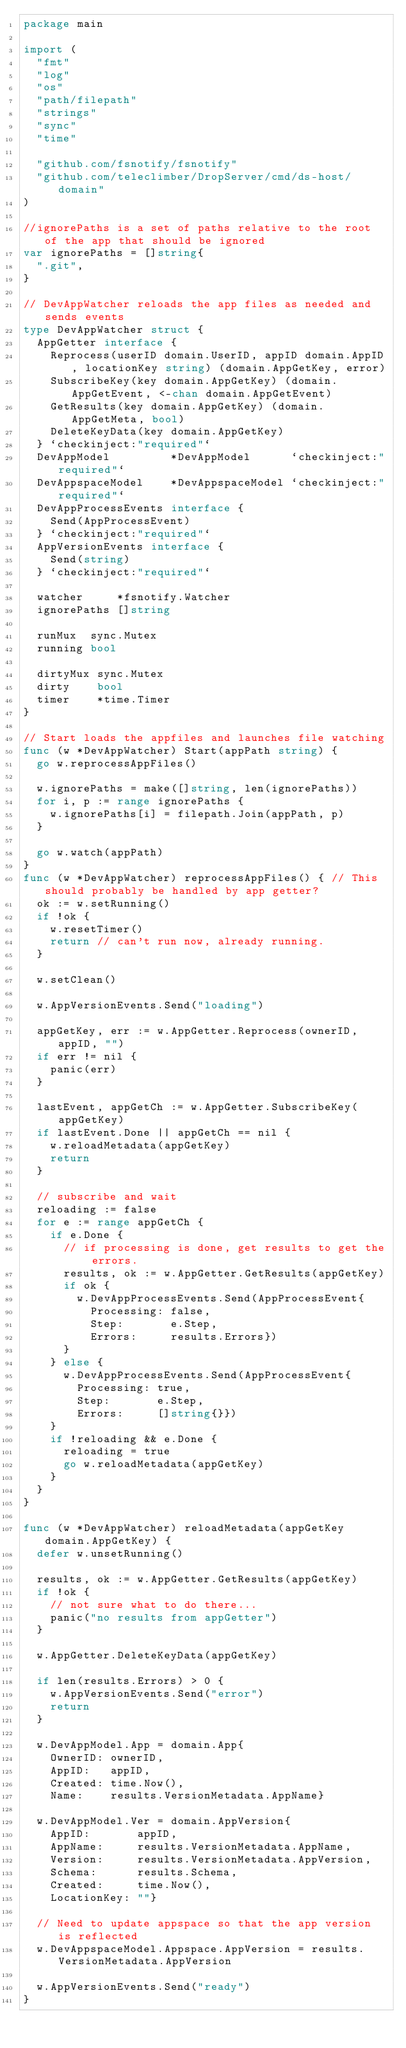<code> <loc_0><loc_0><loc_500><loc_500><_Go_>package main

import (
	"fmt"
	"log"
	"os"
	"path/filepath"
	"strings"
	"sync"
	"time"

	"github.com/fsnotify/fsnotify"
	"github.com/teleclimber/DropServer/cmd/ds-host/domain"
)

//ignorePaths is a set of paths relative to the root of the app that should be ignored
var ignorePaths = []string{
	".git",
}

// DevAppWatcher reloads the app files as needed and sends events
type DevAppWatcher struct {
	AppGetter interface {
		Reprocess(userID domain.UserID, appID domain.AppID, locationKey string) (domain.AppGetKey, error)
		SubscribeKey(key domain.AppGetKey) (domain.AppGetEvent, <-chan domain.AppGetEvent)
		GetResults(key domain.AppGetKey) (domain.AppGetMeta, bool)
		DeleteKeyData(key domain.AppGetKey)
	} `checkinject:"required"`
	DevAppModel         *DevAppModel      `checkinject:"required"`
	DevAppspaceModel    *DevAppspaceModel `checkinject:"required"`
	DevAppProcessEvents interface {
		Send(AppProcessEvent)
	} `checkinject:"required"`
	AppVersionEvents interface {
		Send(string)
	} `checkinject:"required"`

	watcher     *fsnotify.Watcher
	ignorePaths []string

	runMux  sync.Mutex
	running bool

	dirtyMux sync.Mutex
	dirty    bool
	timer    *time.Timer
}

// Start loads the appfiles and launches file watching
func (w *DevAppWatcher) Start(appPath string) {
	go w.reprocessAppFiles()

	w.ignorePaths = make([]string, len(ignorePaths))
	for i, p := range ignorePaths {
		w.ignorePaths[i] = filepath.Join(appPath, p)
	}

	go w.watch(appPath)
}
func (w *DevAppWatcher) reprocessAppFiles() { // This should probably be handled by app getter?
	ok := w.setRunning()
	if !ok {
		w.resetTimer()
		return // can't run now, already running.
	}

	w.setClean()

	w.AppVersionEvents.Send("loading")

	appGetKey, err := w.AppGetter.Reprocess(ownerID, appID, "")
	if err != nil {
		panic(err)
	}

	lastEvent, appGetCh := w.AppGetter.SubscribeKey(appGetKey)
	if lastEvent.Done || appGetCh == nil {
		w.reloadMetadata(appGetKey)
		return
	}

	// subscribe and wait
	reloading := false
	for e := range appGetCh {
		if e.Done {
			// if processing is done, get results to get the errors.
			results, ok := w.AppGetter.GetResults(appGetKey)
			if ok {
				w.DevAppProcessEvents.Send(AppProcessEvent{
					Processing: false,
					Step:       e.Step,
					Errors:     results.Errors})
			}
		} else {
			w.DevAppProcessEvents.Send(AppProcessEvent{
				Processing: true,
				Step:       e.Step,
				Errors:     []string{}})
		}
		if !reloading && e.Done {
			reloading = true
			go w.reloadMetadata(appGetKey)
		}
	}
}

func (w *DevAppWatcher) reloadMetadata(appGetKey domain.AppGetKey) {
	defer w.unsetRunning()

	results, ok := w.AppGetter.GetResults(appGetKey)
	if !ok {
		// not sure what to do there...
		panic("no results from appGetter")
	}

	w.AppGetter.DeleteKeyData(appGetKey)

	if len(results.Errors) > 0 {
		w.AppVersionEvents.Send("error")
		return
	}

	w.DevAppModel.App = domain.App{
		OwnerID: ownerID,
		AppID:   appID,
		Created: time.Now(),
		Name:    results.VersionMetadata.AppName}

	w.DevAppModel.Ver = domain.AppVersion{
		AppID:       appID,
		AppName:     results.VersionMetadata.AppName,
		Version:     results.VersionMetadata.AppVersion,
		Schema:      results.Schema,
		Created:     time.Now(),
		LocationKey: ""}

	// Need to update appspace so that the app version is reflected
	w.DevAppspaceModel.Appspace.AppVersion = results.VersionMetadata.AppVersion

	w.AppVersionEvents.Send("ready")
}
</code> 